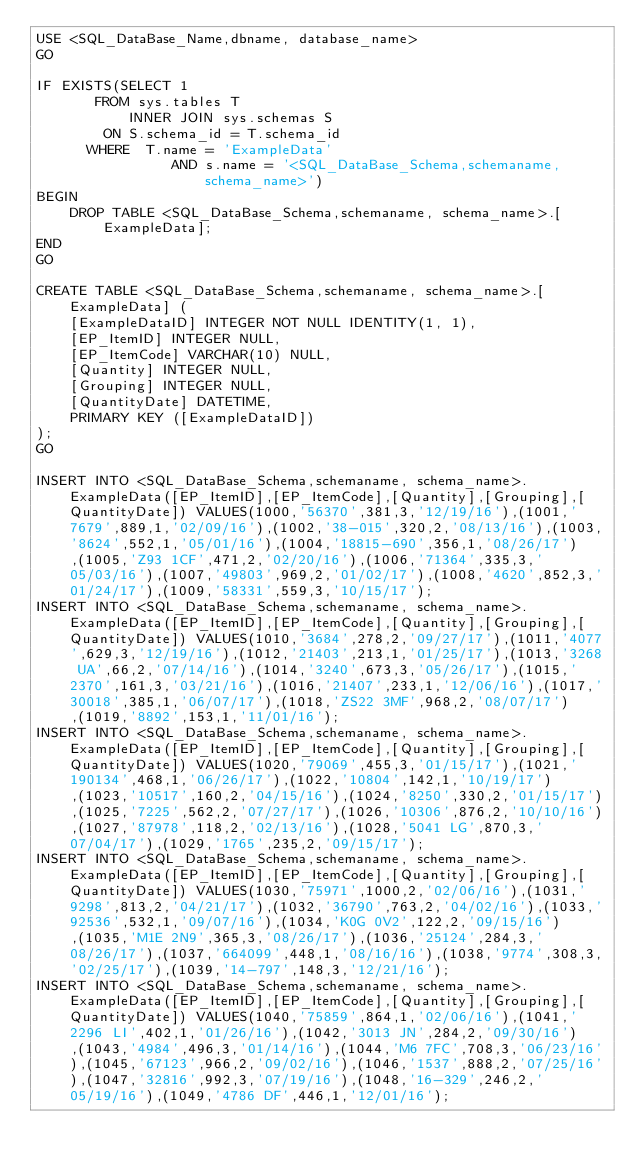Convert code to text. <code><loc_0><loc_0><loc_500><loc_500><_SQL_>USE <SQL_DataBase_Name,dbname, database_name>
GO

IF EXISTS(SELECT 1 
		   FROM sys.tables T
           INNER JOIN sys.schemas S
				ON S.schema_id = T.schema_id 
			WHERE  T.name = 'ExampleData'
                AND s.name = '<SQL_DataBase_Schema,schemaname, schema_name>')
BEGIN
    DROP TABLE <SQL_DataBase_Schema,schemaname, schema_name>.[ExampleData];
END
GO

CREATE TABLE <SQL_DataBase_Schema,schemaname, schema_name>.[ExampleData] (
    [ExampleDataID] INTEGER NOT NULL IDENTITY(1, 1),
    [EP_ItemID] INTEGER NULL,
    [EP_ItemCode] VARCHAR(10) NULL,
    [Quantity] INTEGER NULL,
    [Grouping] INTEGER NULL,
    [QuantityDate] DATETIME,
    PRIMARY KEY ([ExampleDataID])
);
GO

INSERT INTO <SQL_DataBase_Schema,schemaname, schema_name>.ExampleData([EP_ItemID],[EP_ItemCode],[Quantity],[Grouping],[QuantityDate]) VALUES(1000,'56370',381,3,'12/19/16'),(1001,'7679',889,1,'02/09/16'),(1002,'38-015',320,2,'08/13/16'),(1003,'8624',552,1,'05/01/16'),(1004,'18815-690',356,1,'08/26/17'),(1005,'Z93 1CF',471,2,'02/20/16'),(1006,'71364',335,3,'05/03/16'),(1007,'49803',969,2,'01/02/17'),(1008,'4620',852,3,'01/24/17'),(1009,'58331',559,3,'10/15/17');
INSERT INTO <SQL_DataBase_Schema,schemaname, schema_name>.ExampleData([EP_ItemID],[EP_ItemCode],[Quantity],[Grouping],[QuantityDate]) VALUES(1010,'3684',278,2,'09/27/17'),(1011,'4077',629,3,'12/19/16'),(1012,'21403',213,1,'01/25/17'),(1013,'3268 UA',66,2,'07/14/16'),(1014,'3240',673,3,'05/26/17'),(1015,'2370',161,3,'03/21/16'),(1016,'21407',233,1,'12/06/16'),(1017,'30018',385,1,'06/07/17'),(1018,'ZS22 3MF',968,2,'08/07/17'),(1019,'8892',153,1,'11/01/16');
INSERT INTO <SQL_DataBase_Schema,schemaname, schema_name>.ExampleData([EP_ItemID],[EP_ItemCode],[Quantity],[Grouping],[QuantityDate]) VALUES(1020,'79069',455,3,'01/15/17'),(1021,'190134',468,1,'06/26/17'),(1022,'10804',142,1,'10/19/17'),(1023,'10517',160,2,'04/15/16'),(1024,'8250',330,2,'01/15/17'),(1025,'7225',562,2,'07/27/17'),(1026,'10306',876,2,'10/10/16'),(1027,'87978',118,2,'02/13/16'),(1028,'5041 LG',870,3,'07/04/17'),(1029,'1765',235,2,'09/15/17');
INSERT INTO <SQL_DataBase_Schema,schemaname, schema_name>.ExampleData([EP_ItemID],[EP_ItemCode],[Quantity],[Grouping],[QuantityDate]) VALUES(1030,'75971',1000,2,'02/06/16'),(1031,'9298',813,2,'04/21/17'),(1032,'36790',763,2,'04/02/16'),(1033,'92536',532,1,'09/07/16'),(1034,'K0G 0V2',122,2,'09/15/16'),(1035,'M1E 2N9',365,3,'08/26/17'),(1036,'25124',284,3,'08/26/17'),(1037,'664099',448,1,'08/16/16'),(1038,'9774',308,3,'02/25/17'),(1039,'14-797',148,3,'12/21/16');
INSERT INTO <SQL_DataBase_Schema,schemaname, schema_name>.ExampleData([EP_ItemID],[EP_ItemCode],[Quantity],[Grouping],[QuantityDate]) VALUES(1040,'75859',864,1,'02/06/16'),(1041,'2296 LI',402,1,'01/26/16'),(1042,'3013 JN',284,2,'09/30/16'),(1043,'4984',496,3,'01/14/16'),(1044,'M6 7FC',708,3,'06/23/16'),(1045,'67123',966,2,'09/02/16'),(1046,'1537',888,2,'07/25/16'),(1047,'32816',992,3,'07/19/16'),(1048,'16-329',246,2,'05/19/16'),(1049,'4786 DF',446,1,'12/01/16');</code> 